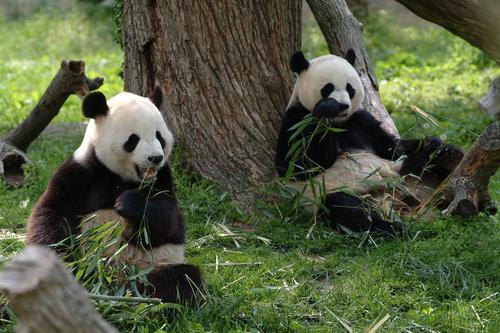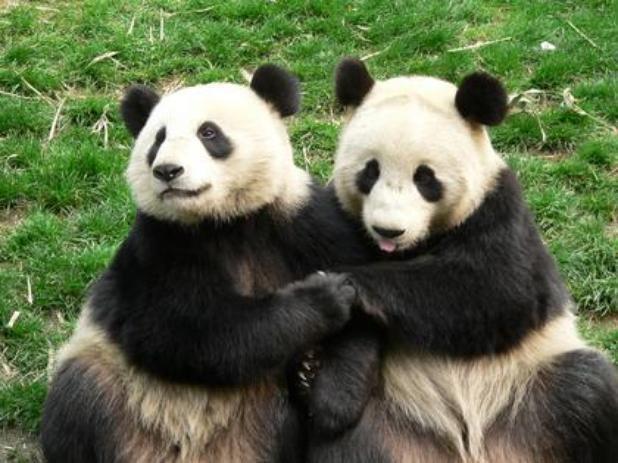The first image is the image on the left, the second image is the image on the right. For the images displayed, is the sentence "There are four pandas in the pair of images." factually correct? Answer yes or no. Yes. The first image is the image on the left, the second image is the image on the right. Examine the images to the left and right. Is the description "There are four pandas." accurate? Answer yes or no. Yes. 